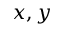<formula> <loc_0><loc_0><loc_500><loc_500>x , y</formula> 